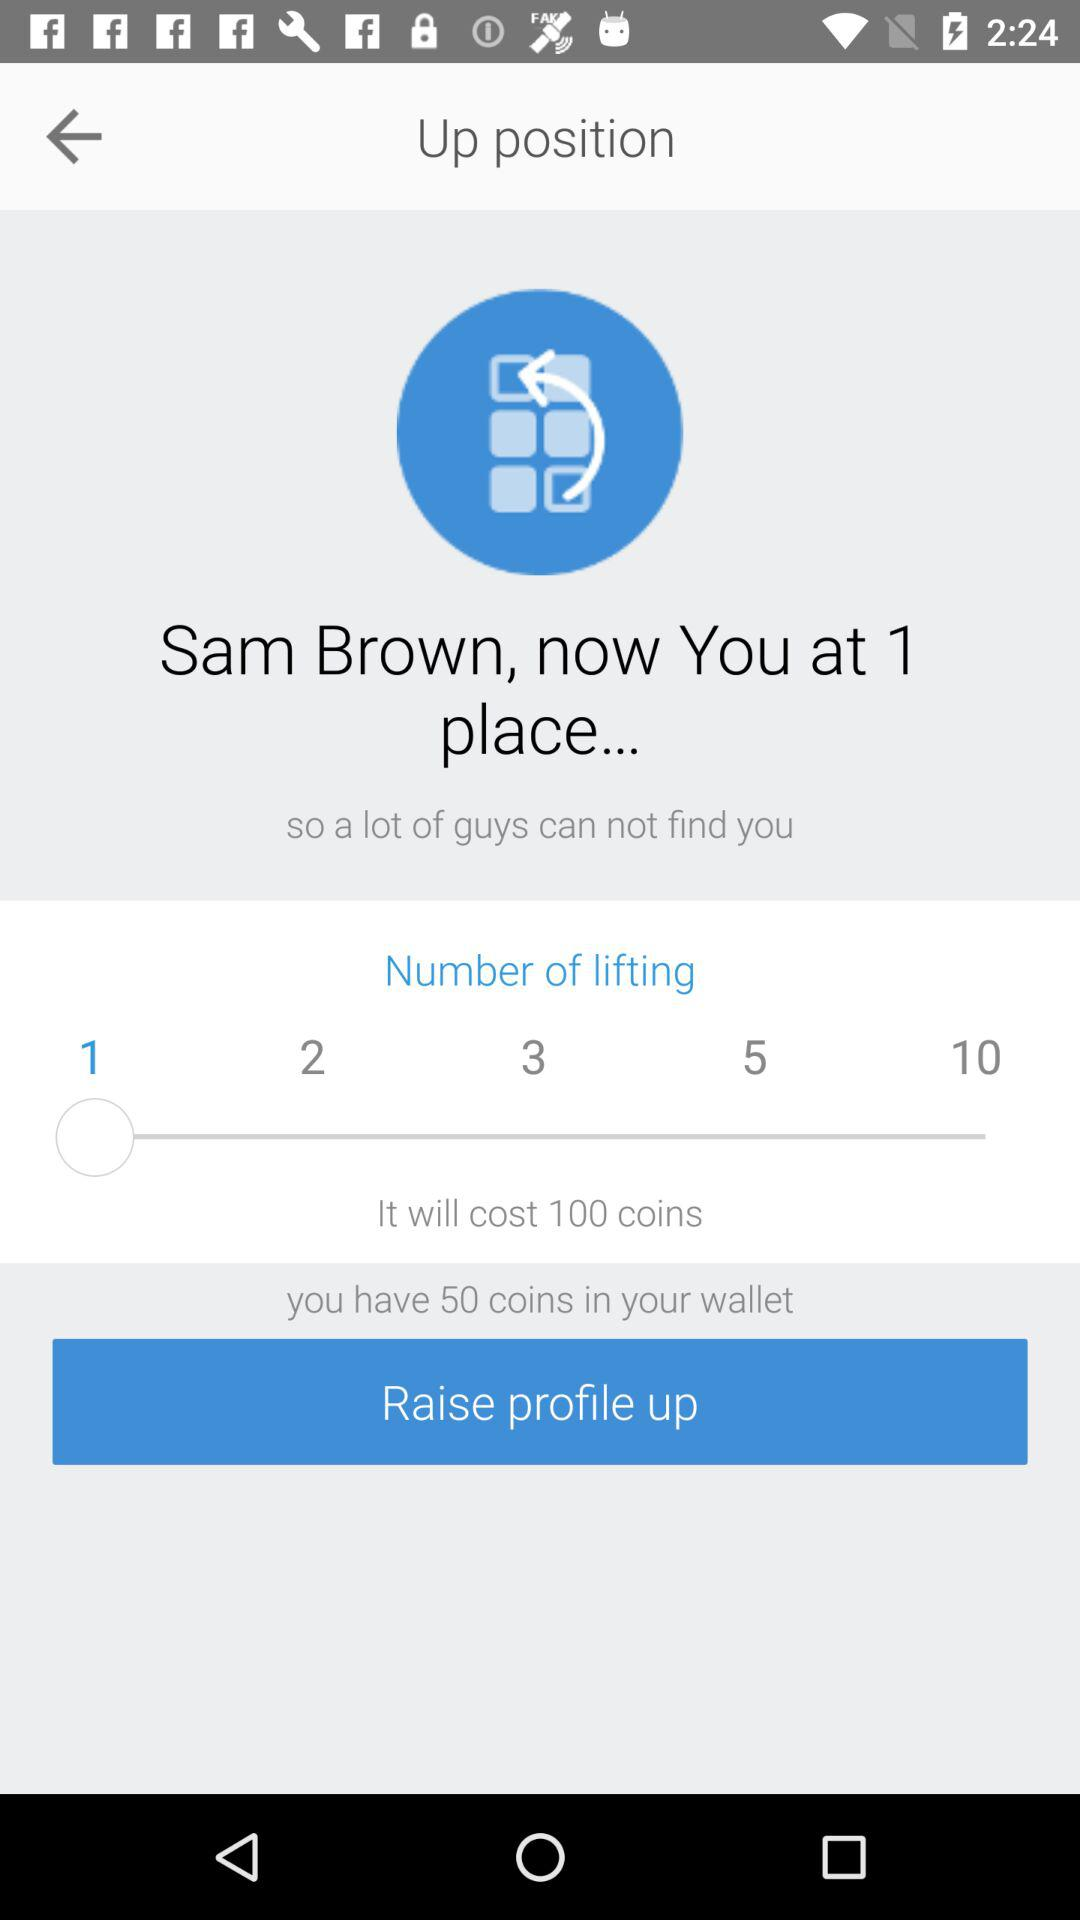What is the name? The name is Sam Brown. 